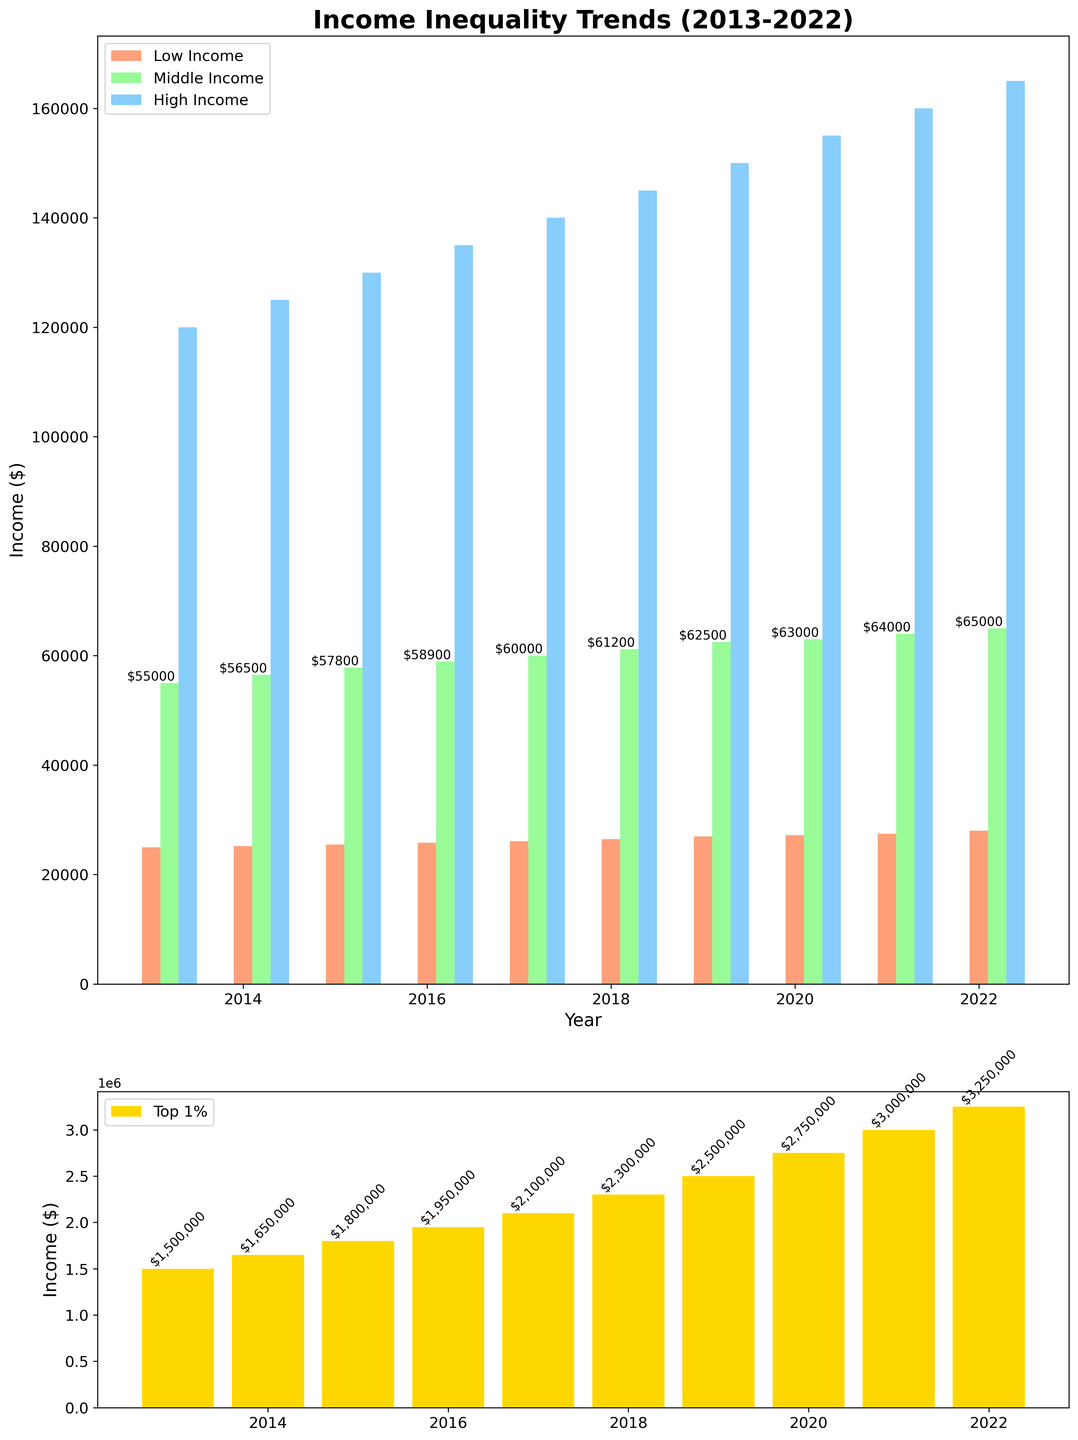What's the average income of the Middle Income group over the decade? Sum up the Middle Income numbers: 55,000 + 56,500 + 57,800 + 58,900 + 60,000 + 61,200 + 62,500 + 63,000 + 64,000 + 65,000 = 603,900. Divide by the number of years (10): 603,900 / 10 = 60,390
Answer: 60,390 Which year shows the highest income for the Top 1%? Check the final bar in the lower subplot for each year. The highest bar corresponds to 2022 with an income of $3,250,000
Answer: 2022 How much did the income for the Low Income group grow from 2013 to 2022? Subtract the 2013 value: $25,000 from the 2022 value: $28,000. The increase is 28,000 - 25,000 = 3,000
Answer: 3,000 Which income group has the least variation in incomes over the decade? Observe all four sets of bars. The Low Income group shows the least annual growth, having bars very close to each other.
Answer: Low Income By what percentage did the Top 1%'s income increase from 2013 to 2017? From 2013 to 2017, the income rose from $1,500,000 to $2,100,000. The increase is 2,100,000 - 1,500,000 = 600,000. Divide by the initial value: 600,000 / 1,500,000 = 0.4. Convert to a percentage: 0.4 * 100 = 40%
Answer: 40% How does the 2022 High Income group's income compare to the 2013 Top 1%'s income? Compare the heights and values of the top bar in each segment. 2022 High Income: $165,000 is much lower than 2013 Top 1%'s: $1,500,000
Answer: much lower What's the income difference between the Middle Income and High Income groups in 2022? Subtract the Middle Income value: $65,000 from the High Income value: $165,000. The difference is 165,000 - 65,000 = 100,000
Answer: 100,000 Which group experienced the highest absolute income increase from 2013 to 2022? Compare all absolute increases. Top 1% increased from $1,500,000 to $3,250,000, a change of 1,750,000, which is the highest.
Answer: Top 1% What is the general trend seen in the income of the Middle Income group from 2013 to 2022? The bars for Middle Income gradually increase in height from left to right, showing a consistent upward trend.
Answer: upward trend How does the 2021 Top 1%'s income compare to the 2019 Top 1%? Compare the bars in the lower subplot for each year. 2021: $3,000,000 is higher than 2019: $2,500,000
Answer: higher 